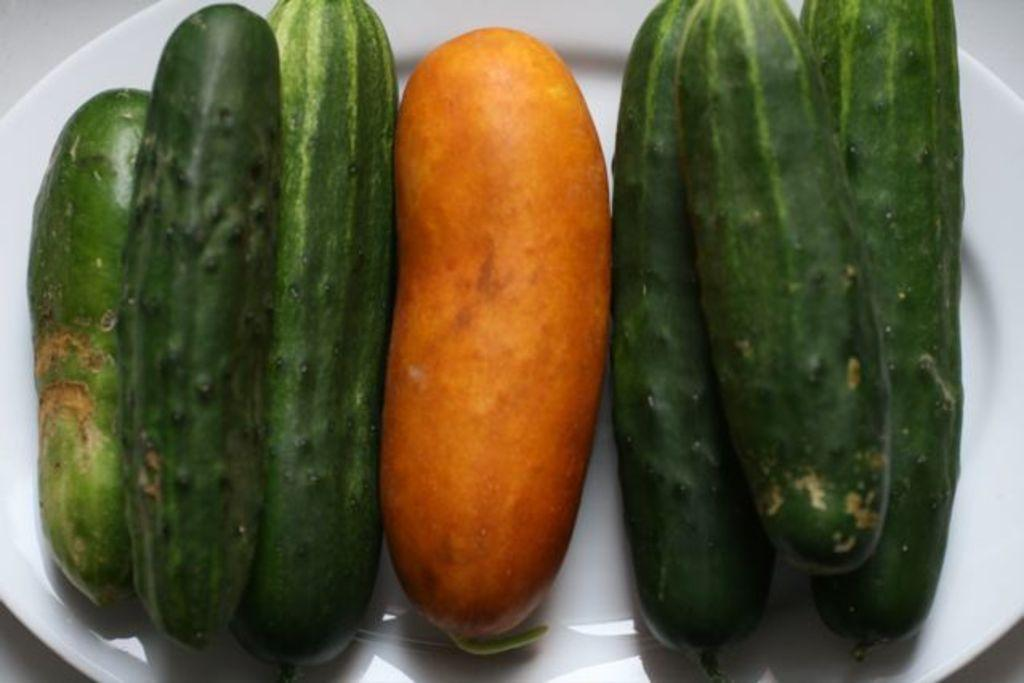What type of food is on the plate in the image? There are cucumbers on a plate in the image. Where is the plate located? The plate is present on a table. What type of impulse can be seen affecting the cucumbers on the plate? There is no impulse affecting the cucumbers on the plate in the image. Are there any worms present on the plate or table in the image? There are no worms present on the plate or table in the image. 